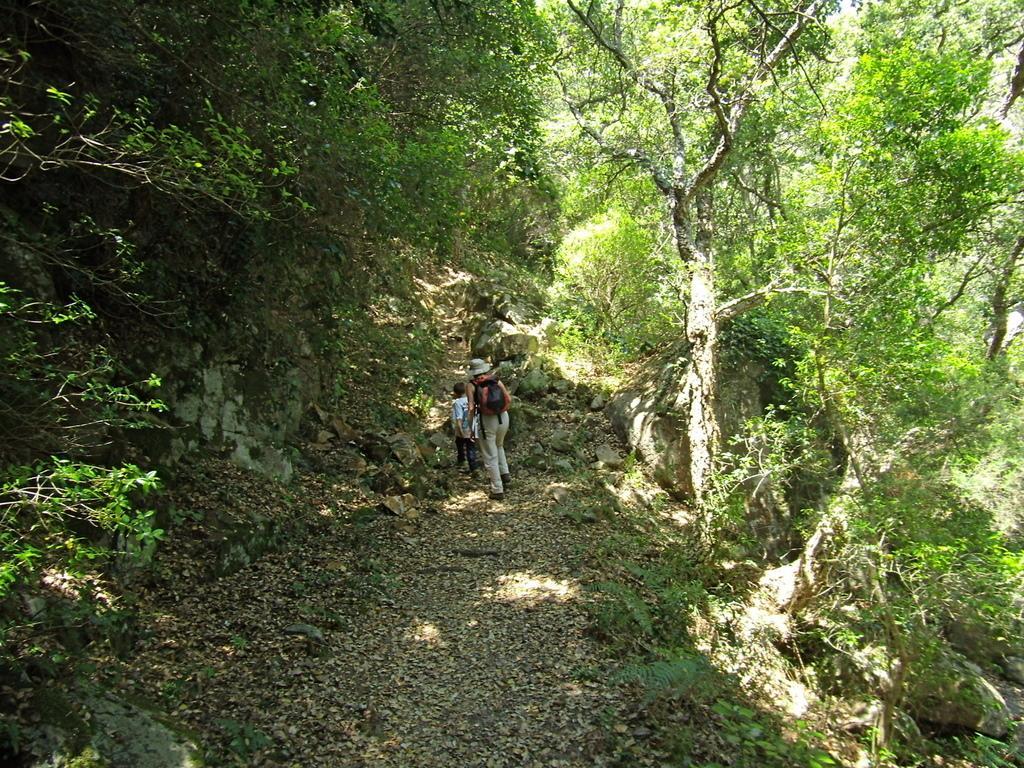Can you describe this image briefly? In this picture I can see people on the surface. I can see trees. 